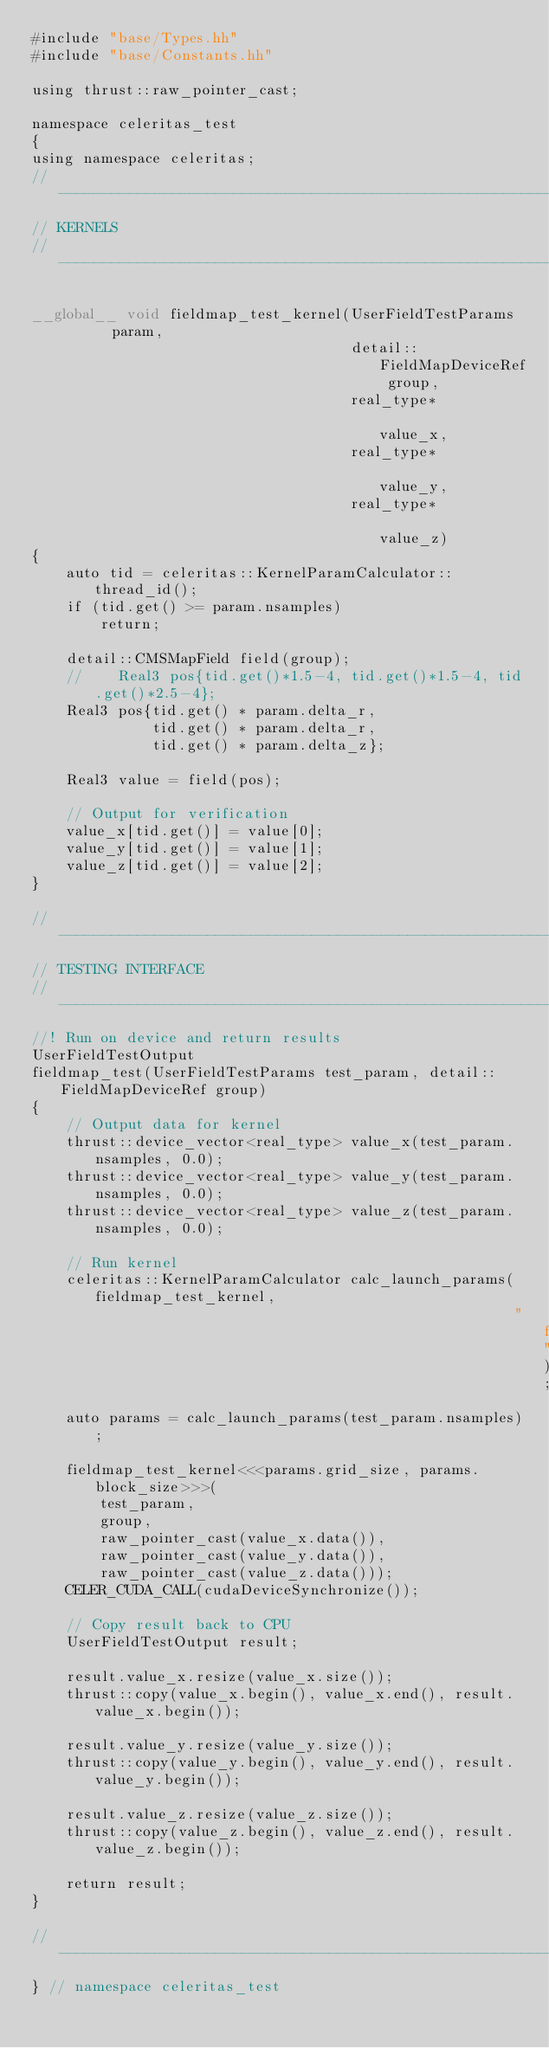Convert code to text. <code><loc_0><loc_0><loc_500><loc_500><_Cuda_>#include "base/Types.hh"
#include "base/Constants.hh"

using thrust::raw_pointer_cast;

namespace celeritas_test
{
using namespace celeritas;
//---------------------------------------------------------------------------//
// KERNELS
//---------------------------------------------------------------------------//

__global__ void fieldmap_test_kernel(UserFieldTestParams       param,
                                     detail::FieldMapDeviceRef group,
                                     real_type*                value_x,
                                     real_type*                value_y,
                                     real_type*                value_z)
{
    auto tid = celeritas::KernelParamCalculator::thread_id();
    if (tid.get() >= param.nsamples)
        return;

    detail::CMSMapField field(group);
    //    Real3 pos{tid.get()*1.5-4, tid.get()*1.5-4, tid.get()*2.5-4};
    Real3 pos{tid.get() * param.delta_r,
              tid.get() * param.delta_r,
              tid.get() * param.delta_z};

    Real3 value = field(pos);

    // Output for verification
    value_x[tid.get()] = value[0];
    value_y[tid.get()] = value[1];
    value_z[tid.get()] = value[2];
}

//---------------------------------------------------------------------------//
// TESTING INTERFACE
//---------------------------------------------------------------------------//
//! Run on device and return results
UserFieldTestOutput
fieldmap_test(UserFieldTestParams test_param, detail::FieldMapDeviceRef group)
{
    // Output data for kernel
    thrust::device_vector<real_type> value_x(test_param.nsamples, 0.0);
    thrust::device_vector<real_type> value_y(test_param.nsamples, 0.0);
    thrust::device_vector<real_type> value_z(test_param.nsamples, 0.0);

    // Run kernel
    celeritas::KernelParamCalculator calc_launch_params(fieldmap_test_kernel,
                                                        "fieldmap_test");
    auto params = calc_launch_params(test_param.nsamples);

    fieldmap_test_kernel<<<params.grid_size, params.block_size>>>(
        test_param,
        group,
        raw_pointer_cast(value_x.data()),
        raw_pointer_cast(value_y.data()),
        raw_pointer_cast(value_z.data()));
    CELER_CUDA_CALL(cudaDeviceSynchronize());

    // Copy result back to CPU
    UserFieldTestOutput result;

    result.value_x.resize(value_x.size());
    thrust::copy(value_x.begin(), value_x.end(), result.value_x.begin());

    result.value_y.resize(value_y.size());
    thrust::copy(value_y.begin(), value_y.end(), result.value_y.begin());

    result.value_z.resize(value_z.size());
    thrust::copy(value_z.begin(), value_z.end(), result.value_z.begin());

    return result;
}

//---------------------------------------------------------------------------//
} // namespace celeritas_test
</code> 